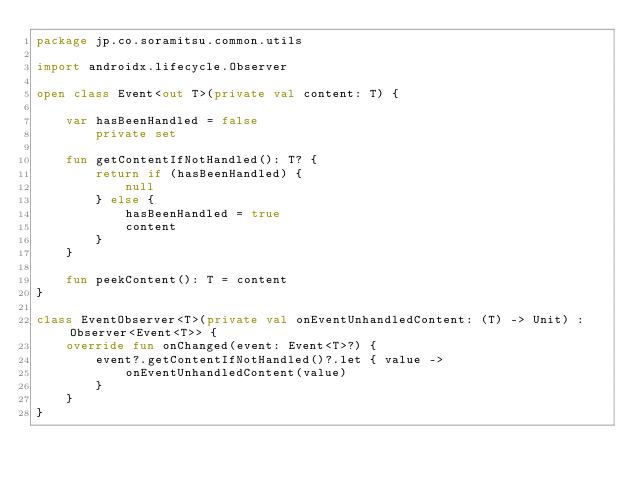Convert code to text. <code><loc_0><loc_0><loc_500><loc_500><_Kotlin_>package jp.co.soramitsu.common.utils

import androidx.lifecycle.Observer

open class Event<out T>(private val content: T) {

    var hasBeenHandled = false
        private set

    fun getContentIfNotHandled(): T? {
        return if (hasBeenHandled) {
            null
        } else {
            hasBeenHandled = true
            content
        }
    }

    fun peekContent(): T = content
}

class EventObserver<T>(private val onEventUnhandledContent: (T) -> Unit) : Observer<Event<T>> {
    override fun onChanged(event: Event<T>?) {
        event?.getContentIfNotHandled()?.let { value ->
            onEventUnhandledContent(value)
        }
    }
}</code> 